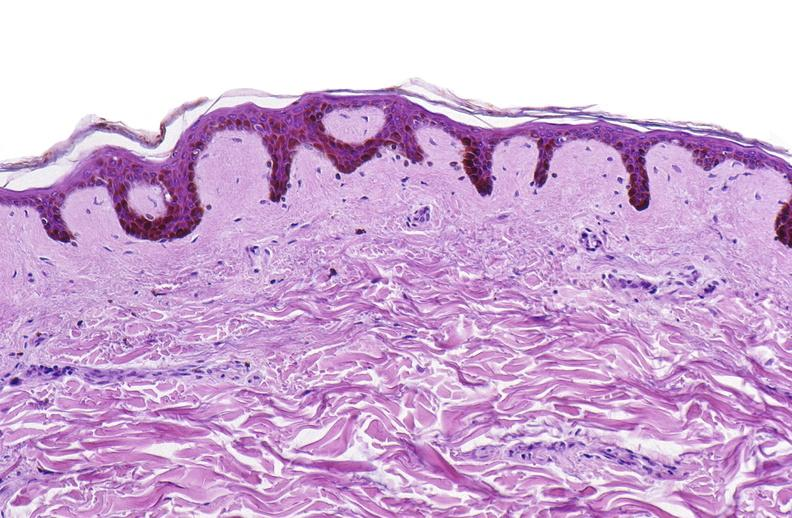does granulomata slide show scleroderma?
Answer the question using a single word or phrase. No 